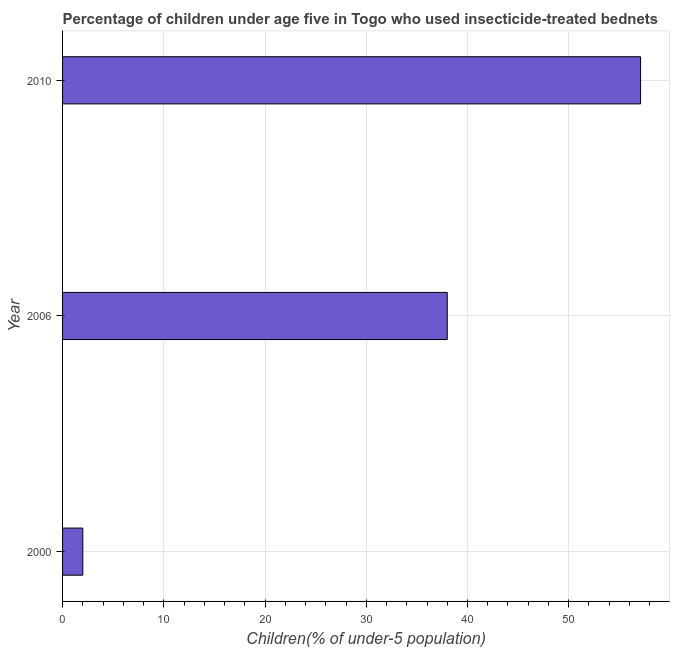Does the graph contain any zero values?
Your answer should be very brief. No. Does the graph contain grids?
Ensure brevity in your answer.  Yes. What is the title of the graph?
Make the answer very short. Percentage of children under age five in Togo who used insecticide-treated bednets. What is the label or title of the X-axis?
Offer a very short reply. Children(% of under-5 population). What is the label or title of the Y-axis?
Your answer should be very brief. Year. What is the percentage of children who use of insecticide-treated bed nets in 2000?
Give a very brief answer. 2. Across all years, what is the maximum percentage of children who use of insecticide-treated bed nets?
Provide a short and direct response. 57.1. What is the sum of the percentage of children who use of insecticide-treated bed nets?
Give a very brief answer. 97.1. What is the difference between the percentage of children who use of insecticide-treated bed nets in 2000 and 2010?
Your answer should be very brief. -55.1. What is the average percentage of children who use of insecticide-treated bed nets per year?
Provide a short and direct response. 32.37. In how many years, is the percentage of children who use of insecticide-treated bed nets greater than 48 %?
Keep it short and to the point. 1. What is the ratio of the percentage of children who use of insecticide-treated bed nets in 2000 to that in 2006?
Keep it short and to the point. 0.05. What is the difference between the highest and the second highest percentage of children who use of insecticide-treated bed nets?
Your response must be concise. 19.1. What is the difference between the highest and the lowest percentage of children who use of insecticide-treated bed nets?
Your response must be concise. 55.1. Are all the bars in the graph horizontal?
Offer a very short reply. Yes. What is the difference between two consecutive major ticks on the X-axis?
Make the answer very short. 10. Are the values on the major ticks of X-axis written in scientific E-notation?
Your answer should be very brief. No. What is the Children(% of under-5 population) in 2000?
Offer a terse response. 2. What is the Children(% of under-5 population) of 2010?
Your answer should be very brief. 57.1. What is the difference between the Children(% of under-5 population) in 2000 and 2006?
Make the answer very short. -36. What is the difference between the Children(% of under-5 population) in 2000 and 2010?
Offer a very short reply. -55.1. What is the difference between the Children(% of under-5 population) in 2006 and 2010?
Your response must be concise. -19.1. What is the ratio of the Children(% of under-5 population) in 2000 to that in 2006?
Offer a terse response. 0.05. What is the ratio of the Children(% of under-5 population) in 2000 to that in 2010?
Your answer should be compact. 0.04. What is the ratio of the Children(% of under-5 population) in 2006 to that in 2010?
Provide a succinct answer. 0.67. 